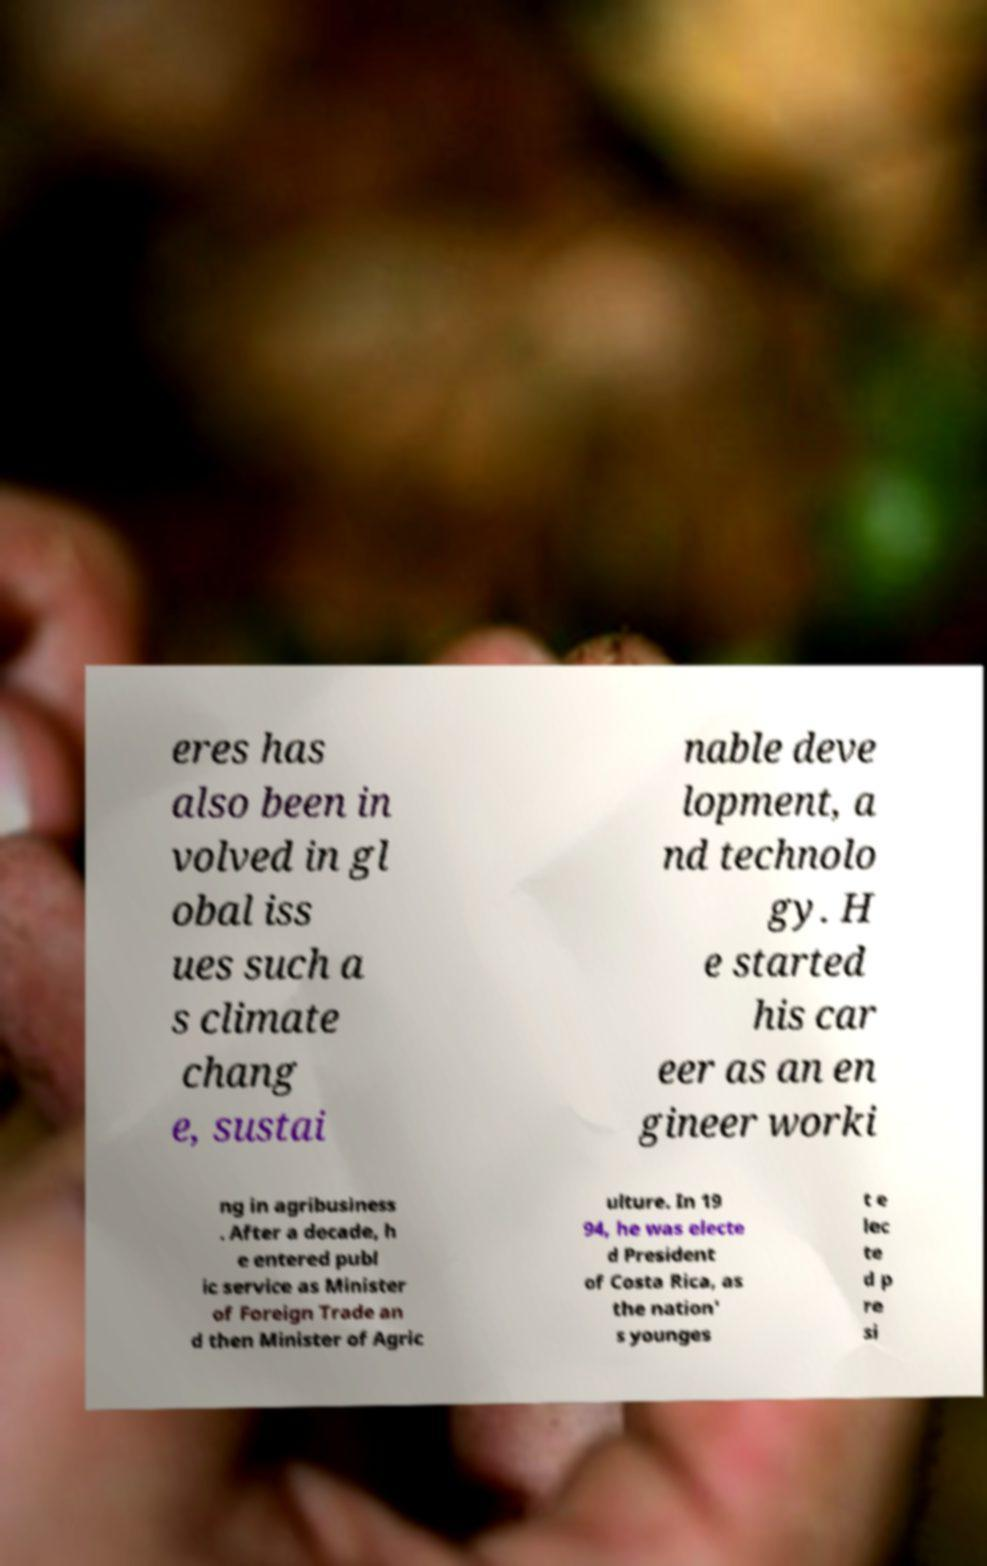Please read and relay the text visible in this image. What does it say? eres has also been in volved in gl obal iss ues such a s climate chang e, sustai nable deve lopment, a nd technolo gy. H e started his car eer as an en gineer worki ng in agribusiness . After a decade, h e entered publ ic service as Minister of Foreign Trade an d then Minister of Agric ulture. In 19 94, he was electe d President of Costa Rica, as the nation' s younges t e lec te d p re si 